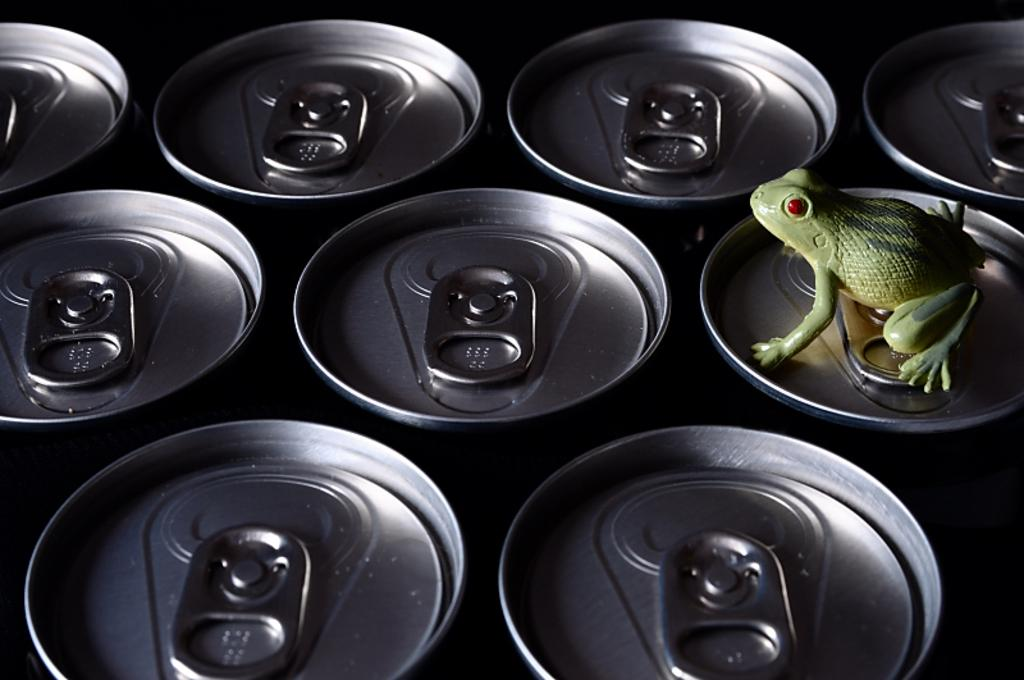What is the main subject of the image? The main subject of the image is a tin. What is on top of the tin? There is a toy frog on the tin in the image. What type of tent can be seen in the image? There is no tent present in the image; it features a tin with a toy frog on top. What color is the notebook in the image? There is no notebook present in the image. 